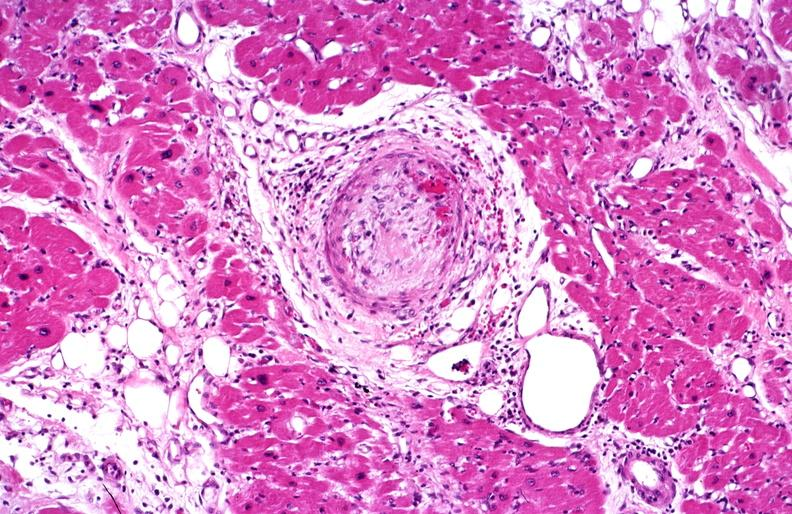does this image show heart, polyarteritis nodosa?
Answer the question using a single word or phrase. Yes 